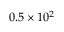<formula> <loc_0><loc_0><loc_500><loc_500>0 . 5 \times 1 0 ^ { 2 }</formula> 